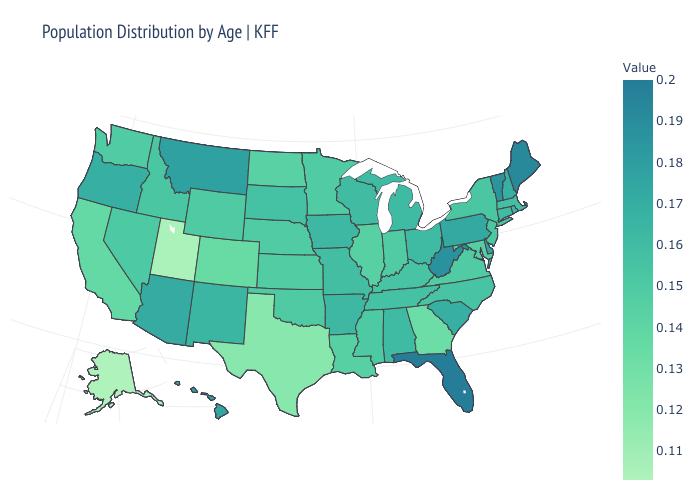Is the legend a continuous bar?
Be succinct. Yes. Among the states that border Louisiana , does Texas have the highest value?
Quick response, please. No. Does Alabama have the lowest value in the South?
Quick response, please. No. Does Alaska have the lowest value in the USA?
Give a very brief answer. Yes. Is the legend a continuous bar?
Keep it brief. Yes. 